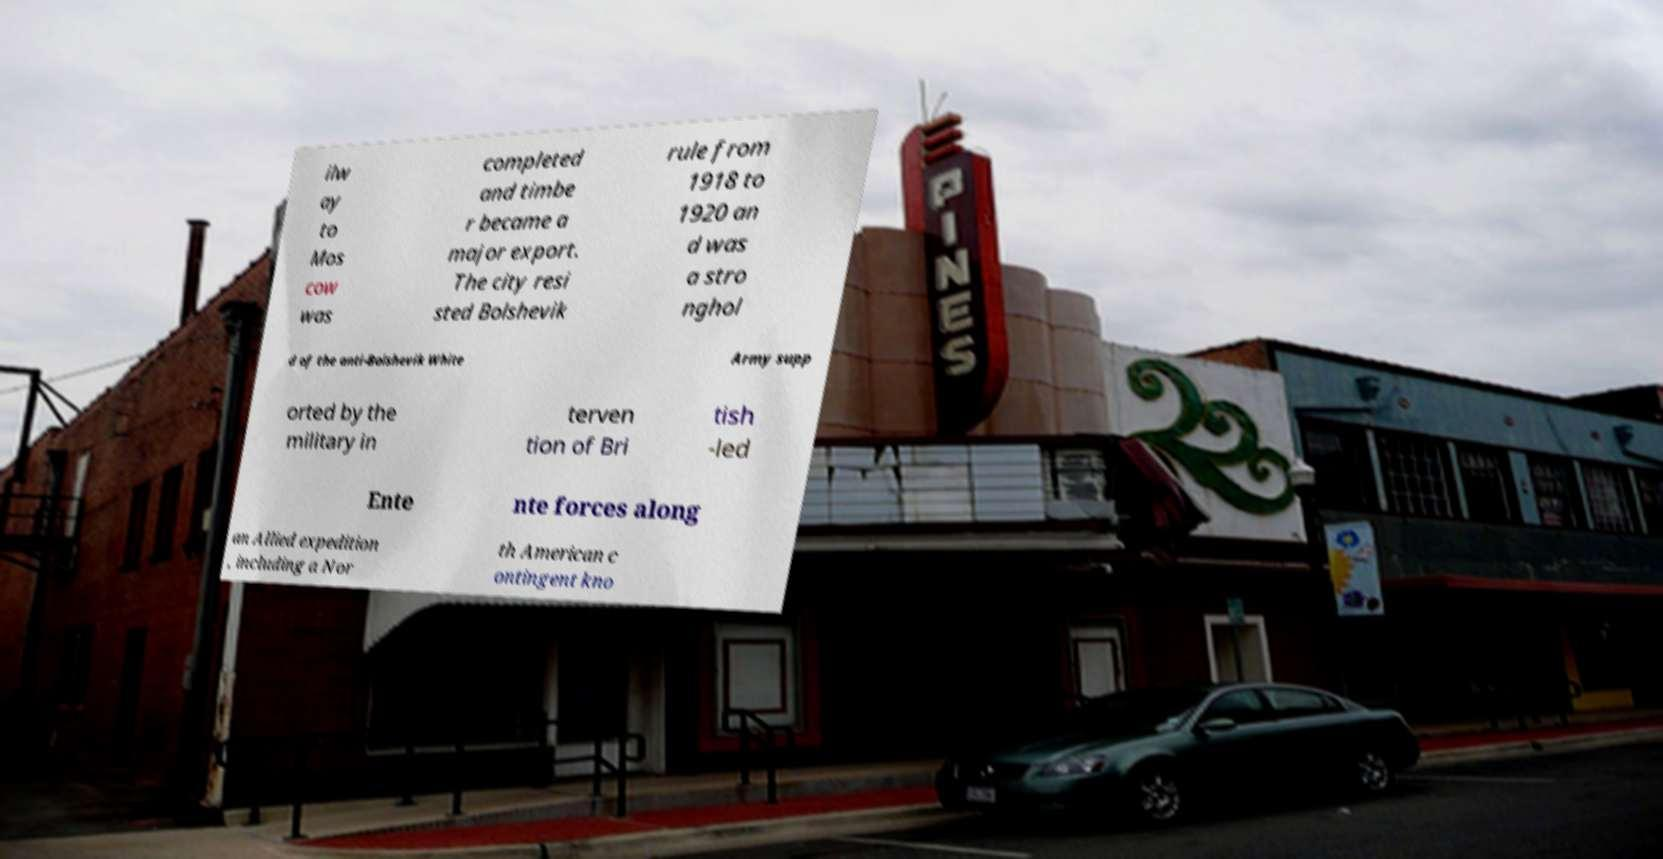What messages or text are displayed in this image? I need them in a readable, typed format. ilw ay to Mos cow was completed and timbe r became a major export. The city resi sted Bolshevik rule from 1918 to 1920 an d was a stro nghol d of the anti-Bolshevik White Army supp orted by the military in terven tion of Bri tish -led Ente nte forces along an Allied expedition , including a Nor th American c ontingent kno 